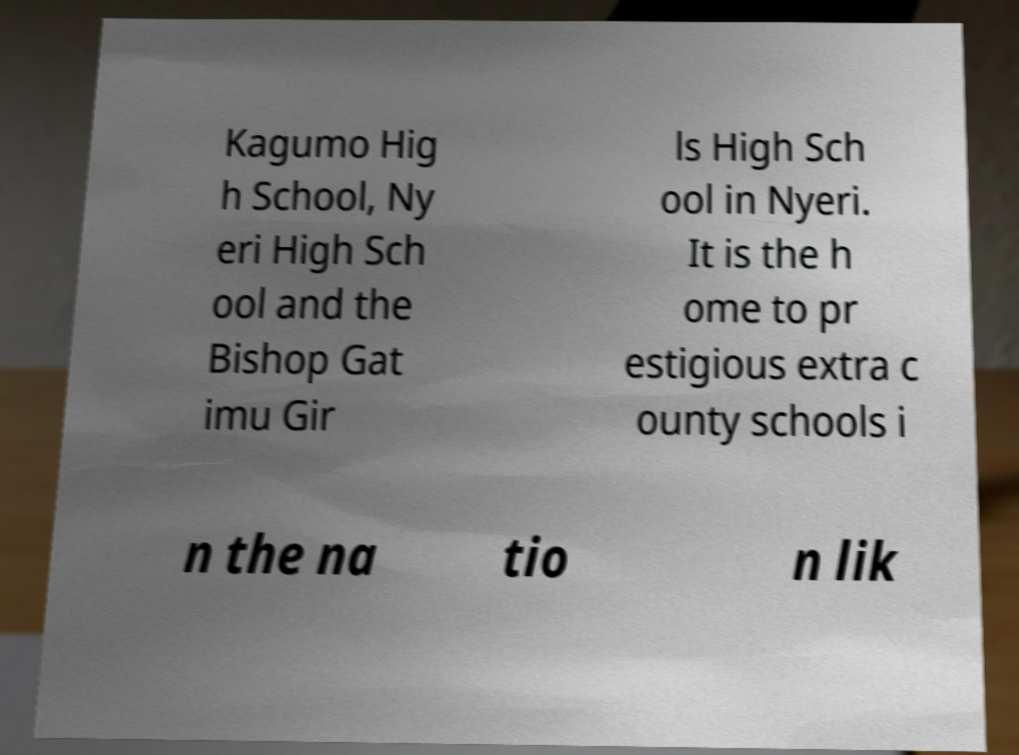Please identify and transcribe the text found in this image. Kagumo Hig h School, Ny eri High Sch ool and the Bishop Gat imu Gir ls High Sch ool in Nyeri. It is the h ome to pr estigious extra c ounty schools i n the na tio n lik 